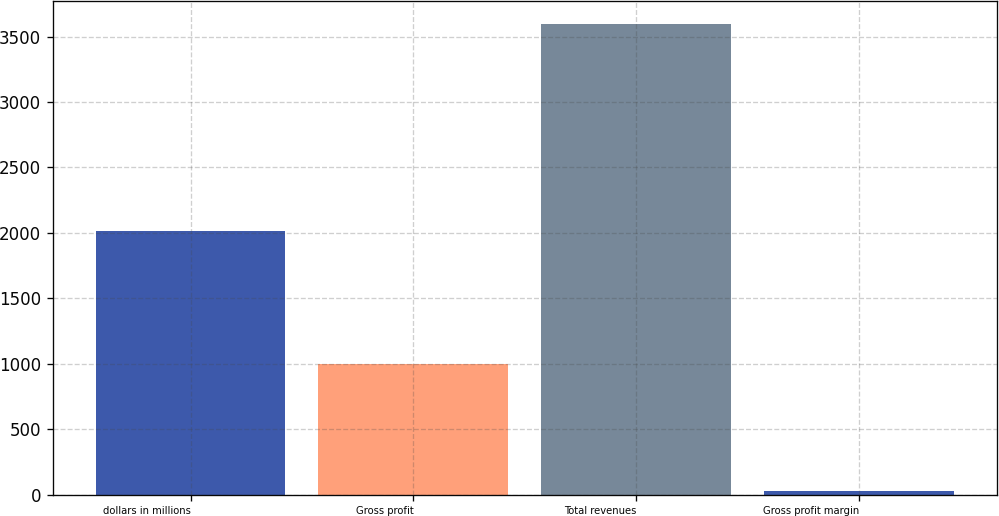Convert chart. <chart><loc_0><loc_0><loc_500><loc_500><bar_chart><fcel>dollars in millions<fcel>Gross profit<fcel>Total revenues<fcel>Gross profit margin<nl><fcel>2016<fcel>1000.8<fcel>3592.7<fcel>27.9<nl></chart> 